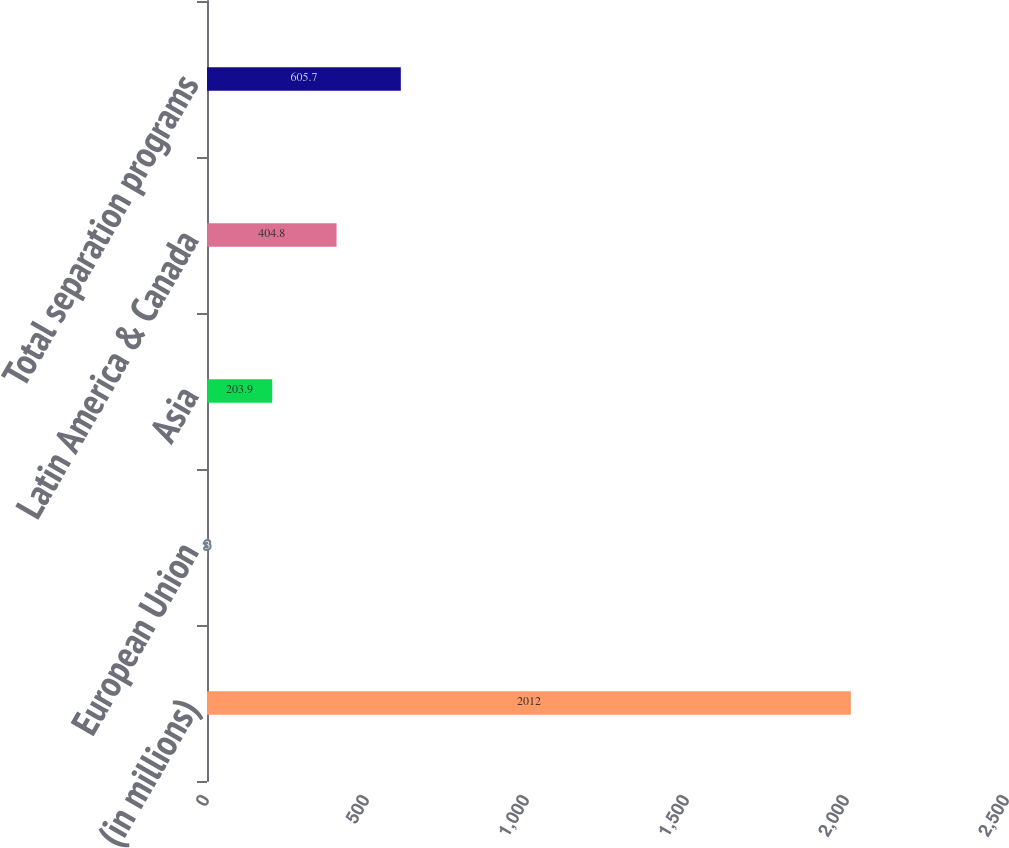<chart> <loc_0><loc_0><loc_500><loc_500><bar_chart><fcel>(in millions)<fcel>European Union<fcel>Asia<fcel>Latin America & Canada<fcel>Total separation programs<nl><fcel>2012<fcel>3<fcel>203.9<fcel>404.8<fcel>605.7<nl></chart> 